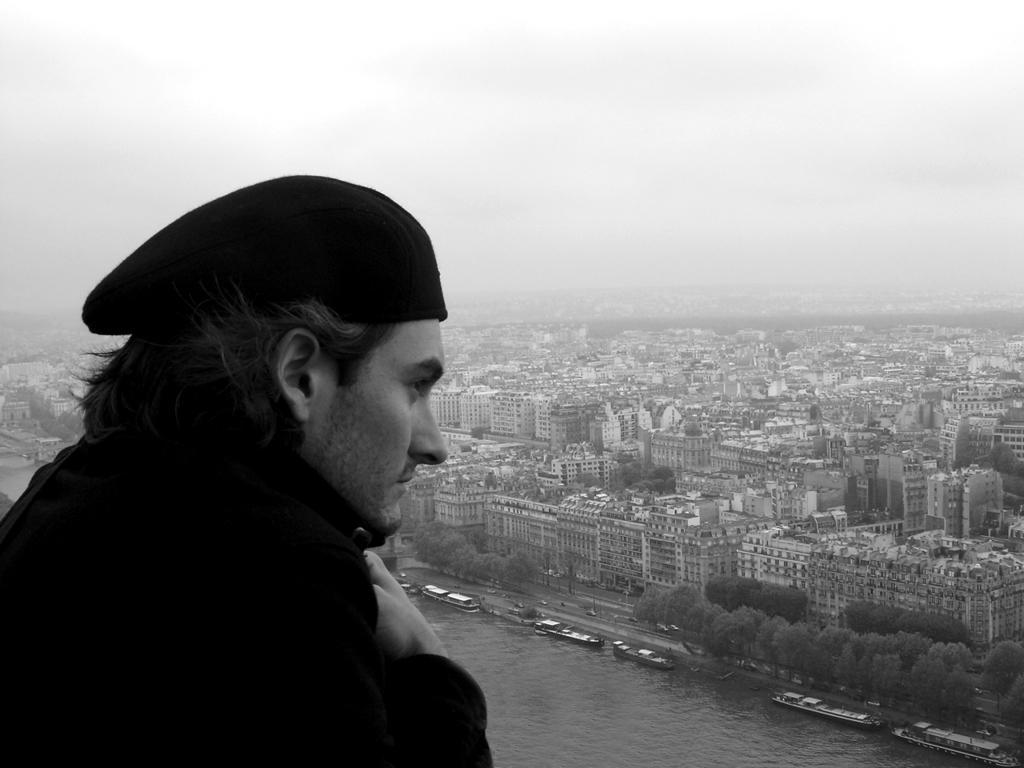Could you give a brief overview of what you see in this image? In this image I can see a man and I can see he is wearing a cap. In the background I can see number of buildings, number of trees, water and in it I can see few boats. I can also see this image is black and white in colour. 